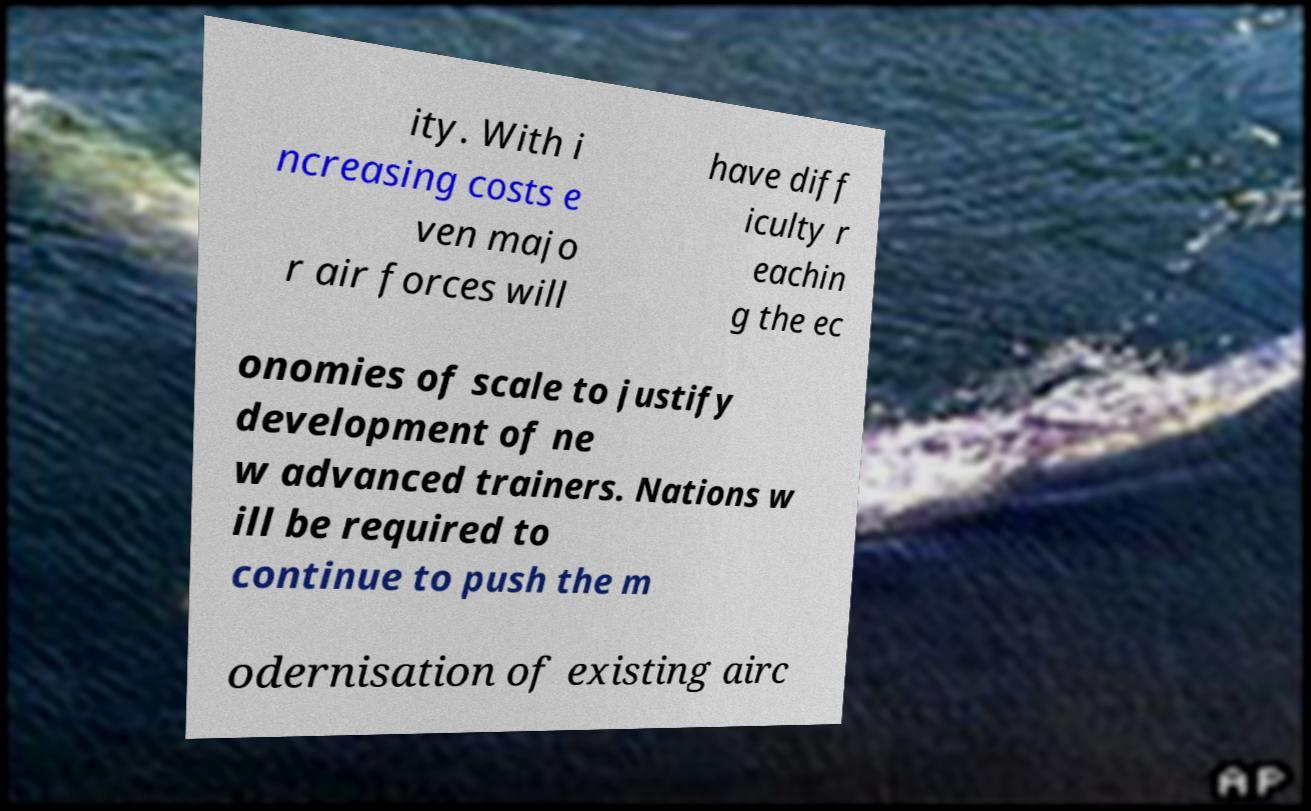Please read and relay the text visible in this image. What does it say? ity. With i ncreasing costs e ven majo r air forces will have diff iculty r eachin g the ec onomies of scale to justify development of ne w advanced trainers. Nations w ill be required to continue to push the m odernisation of existing airc 